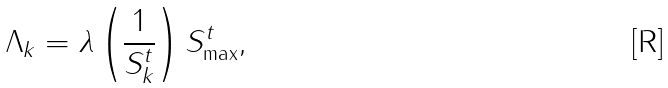<formula> <loc_0><loc_0><loc_500><loc_500>\Lambda _ { k } = \lambda \left ( \frac { 1 } { S _ { k } ^ { t } } \right ) S ^ { t } _ { \max } ,</formula> 